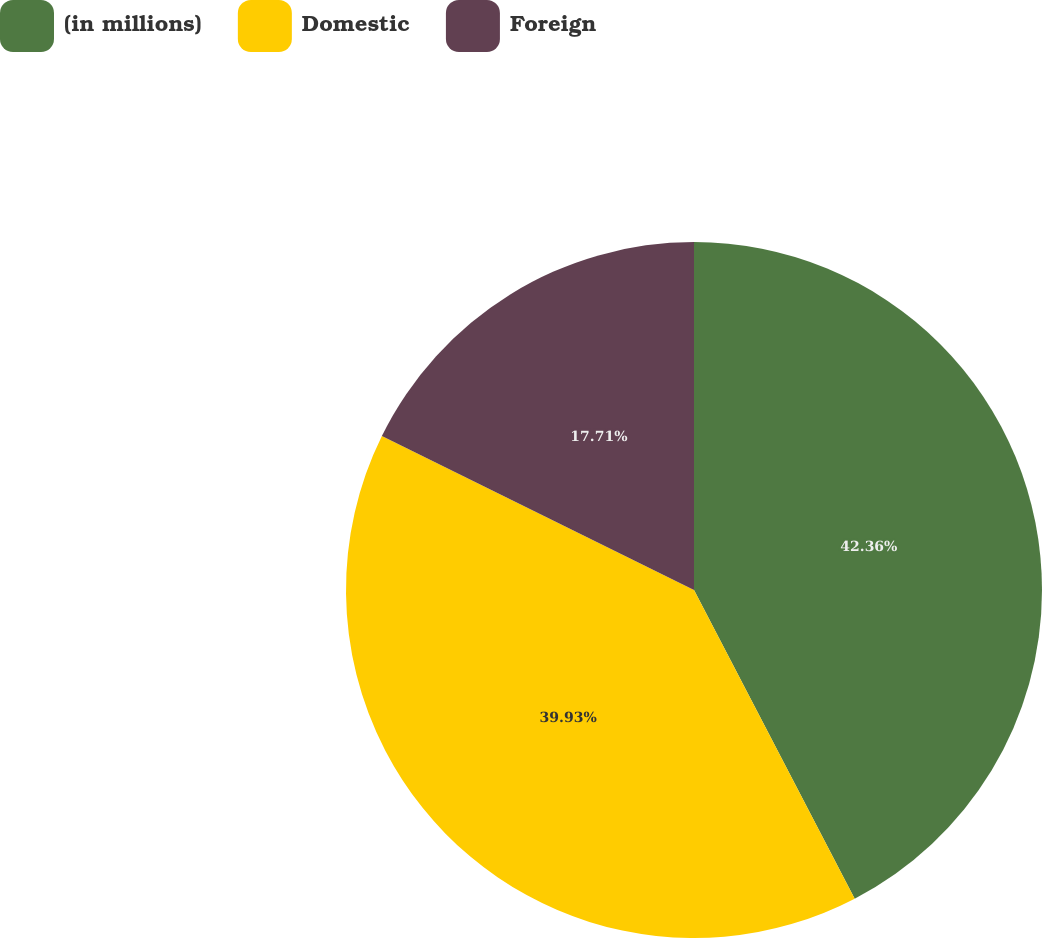<chart> <loc_0><loc_0><loc_500><loc_500><pie_chart><fcel>(in millions)<fcel>Domestic<fcel>Foreign<nl><fcel>42.36%<fcel>39.93%<fcel>17.71%<nl></chart> 